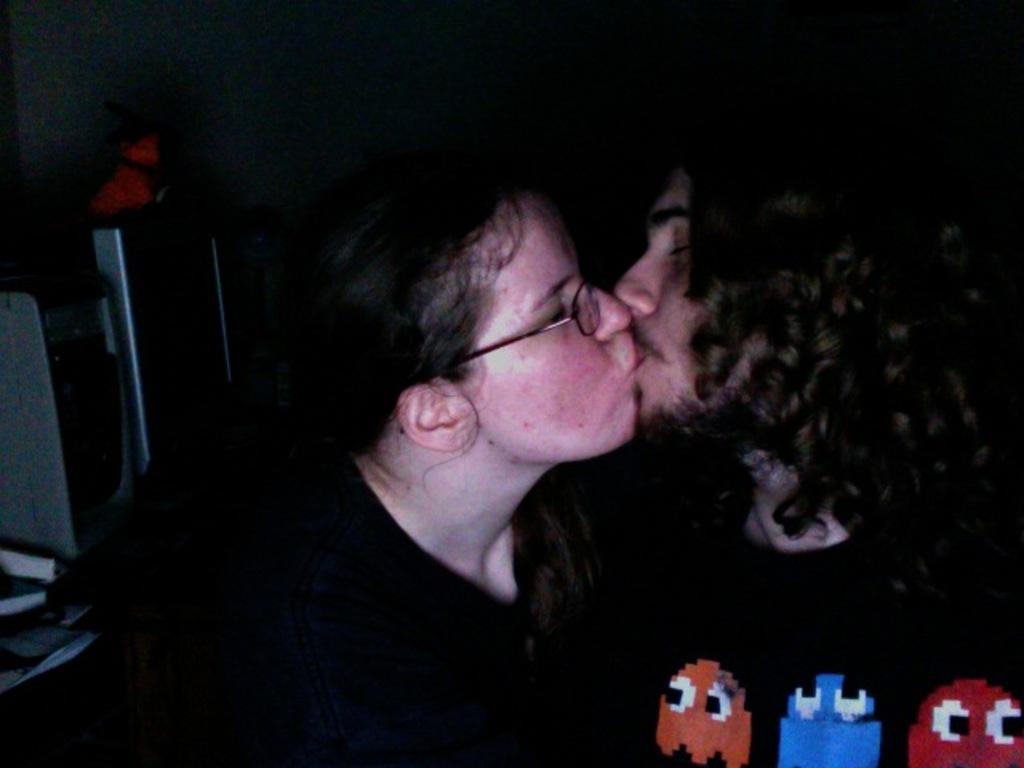How many people are in the image? There are two persons in the image. What are the persons wearing? The persons are wearing clothes. What are the persons doing in the image? The persons are kissing each other. Where can cartoons be found in the image? The cartoons are in the bottom right of the image. What is the health status of the persons in the image? There is no information about the health status of the persons in the image. --- Facts: 1. There is a person in the image. 2. The person is holding a book. 3. The book has a blue cover. 4. The person is sitting on a chair. 5. There is a table next to the person. Absurd Topics: elephant, piano, ocean Conversation: Who is in the image? There is a person in the image. What is the person holding in the image? The person is holding a book. What color is the book cover? The book has a blue cover. What is the person doing in the image? The person is sitting on a chair. What is next to the person in the image? There is a table next to the person. Reasoning: Let's think step by step in order to produce the conversation. We start by identifying the main subject in the image, which is the person. Next, we describe what the person is holding, which is a book. Then, we mention the color of the book cover, which is blue. After that, we describe what the person is doing, which is sitting on a chair. Finally, we mention what is next to the person in the image, which is a table. Absurd Question/Answer: Can you hear the elephant playing the piano in the image? There is no elephant, piano, or ocean present in the image. 